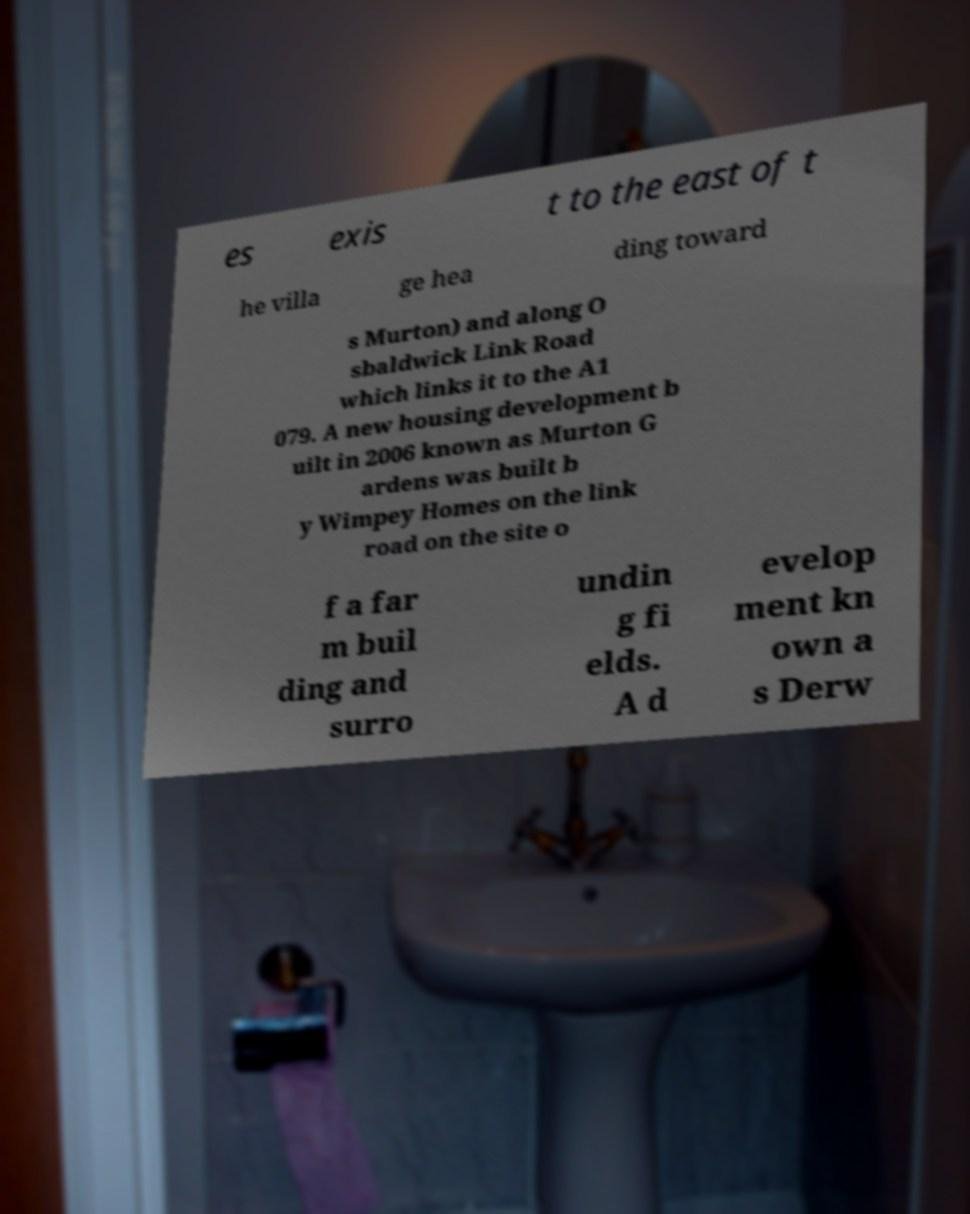There's text embedded in this image that I need extracted. Can you transcribe it verbatim? es exis t to the east of t he villa ge hea ding toward s Murton) and along O sbaldwick Link Road which links it to the A1 079. A new housing development b uilt in 2006 known as Murton G ardens was built b y Wimpey Homes on the link road on the site o f a far m buil ding and surro undin g fi elds. A d evelop ment kn own a s Derw 